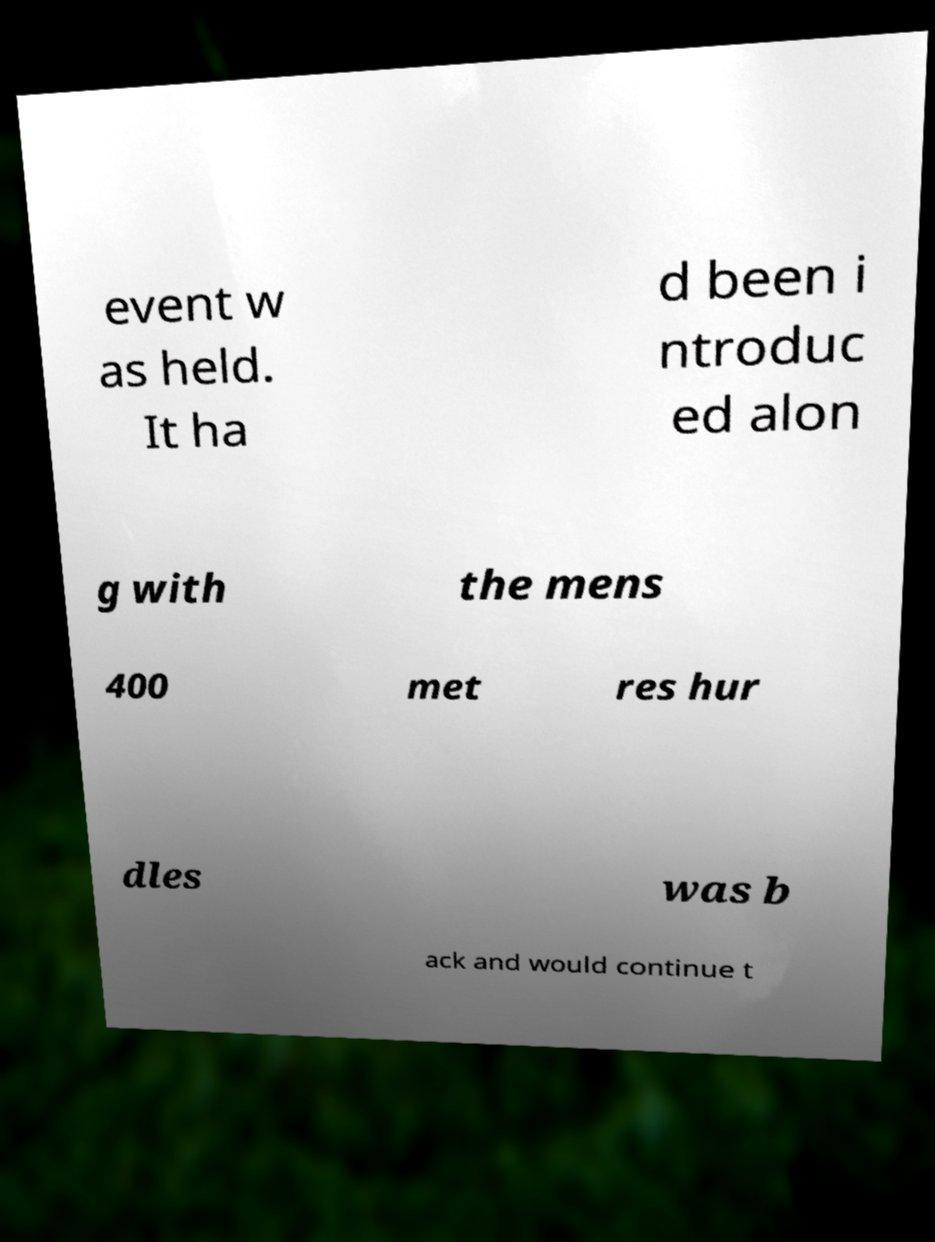What messages or text are displayed in this image? I need them in a readable, typed format. event w as held. It ha d been i ntroduc ed alon g with the mens 400 met res hur dles was b ack and would continue t 